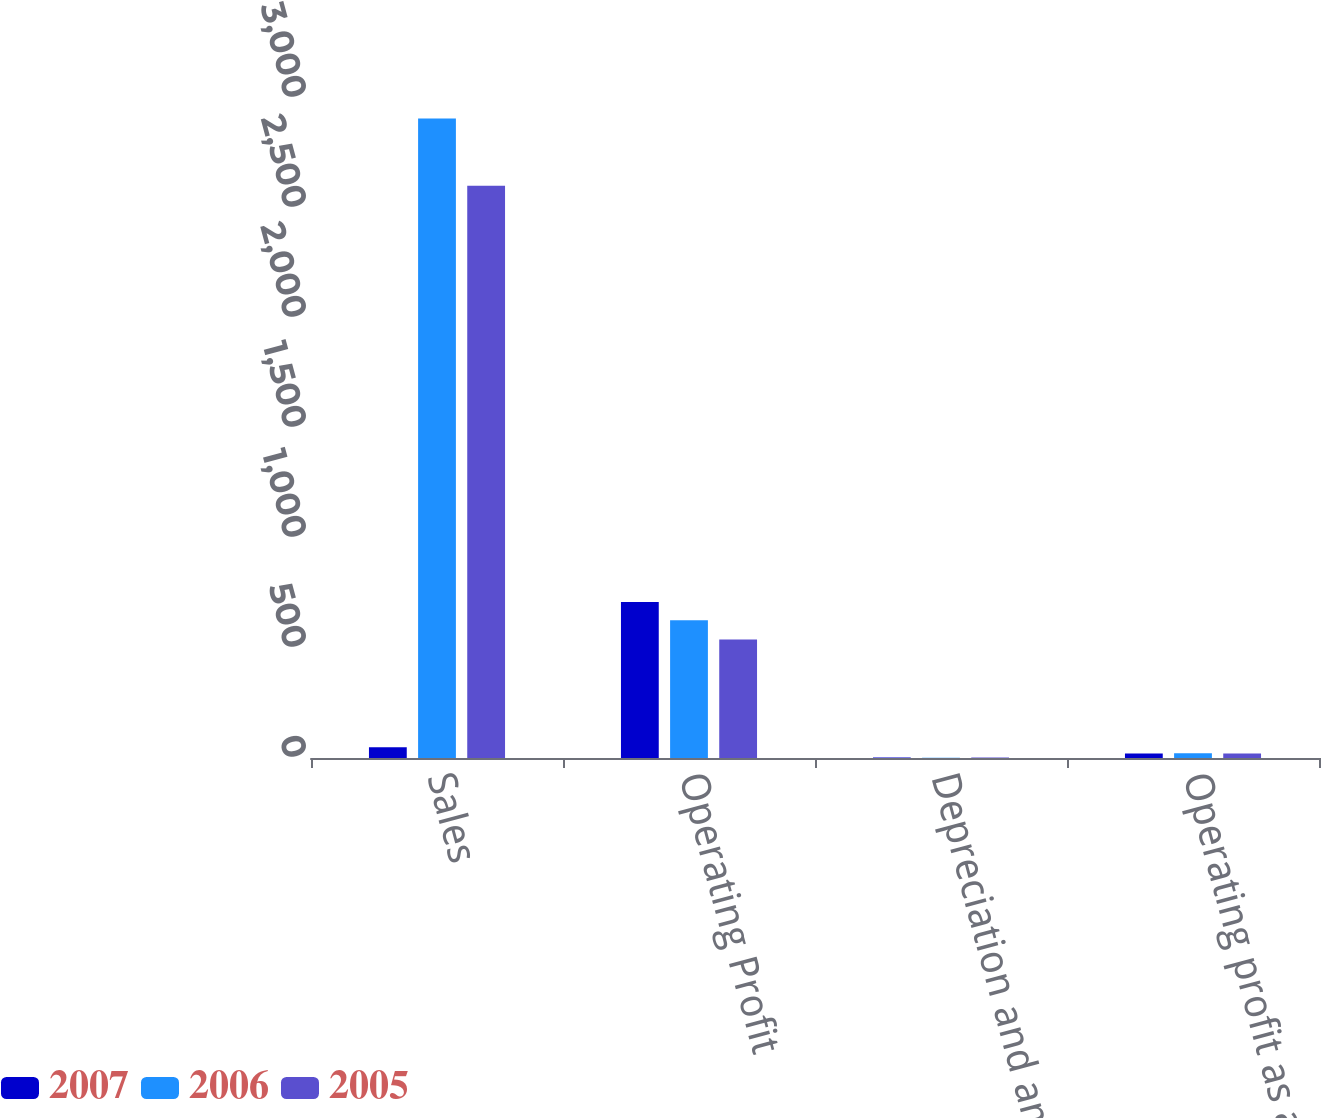<chart> <loc_0><loc_0><loc_500><loc_500><stacked_bar_chart><ecel><fcel>Sales<fcel>Operating Profit<fcel>Depreciation and amortization<fcel>Operating profit as a of sales<nl><fcel>2007<fcel>48.3<fcel>709.5<fcel>1.8<fcel>20.1<nl><fcel>2006<fcel>2906.5<fcel>625.6<fcel>1.7<fcel>21.5<nl><fcel>2005<fcel>2600.6<fcel>538.3<fcel>1.8<fcel>20.7<nl></chart> 